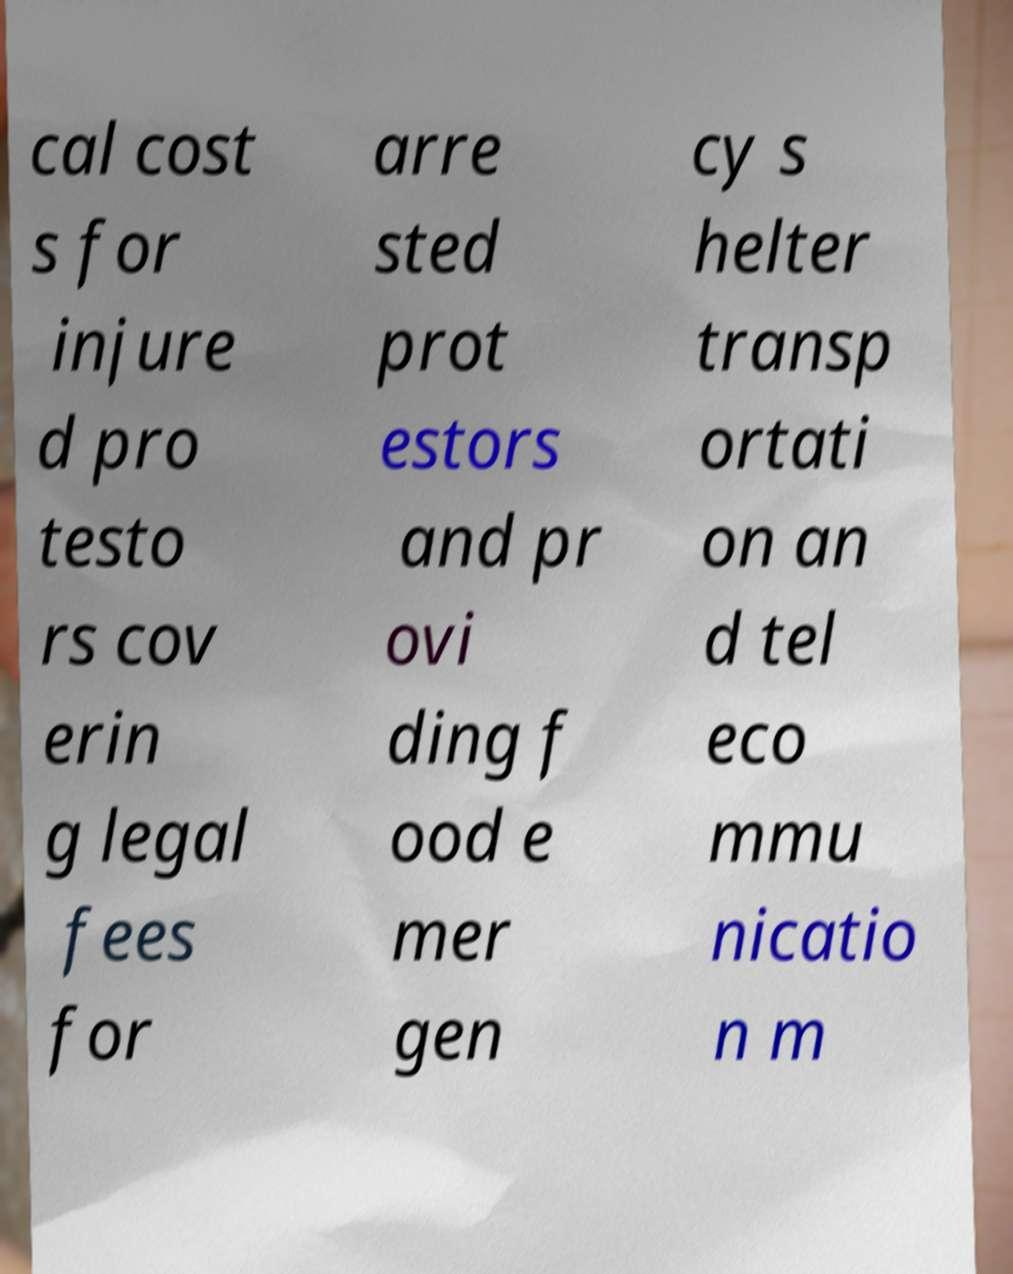Could you extract and type out the text from this image? cal cost s for injure d pro testo rs cov erin g legal fees for arre sted prot estors and pr ovi ding f ood e mer gen cy s helter transp ortati on an d tel eco mmu nicatio n m 